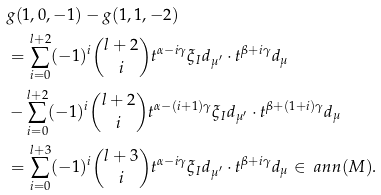<formula> <loc_0><loc_0><loc_500><loc_500>& g ( 1 , 0 , - 1 ) - g ( 1 , 1 , - 2 ) \\ & = \sum _ { i = 0 } ^ { l + 2 } ( - 1 ) ^ { i } \binom { l + 2 } i t ^ { \alpha - i \gamma } \xi _ { I } d _ { \mu ^ { \prime } } \cdot t ^ { \beta + i \gamma } d _ { \mu } \\ & - \sum _ { i = 0 } ^ { l + 2 } ( - 1 ) ^ { i } \binom { l + 2 } i t ^ { \alpha - ( i + 1 ) \gamma } \xi _ { I } d _ { \mu ^ { \prime } } \cdot t ^ { \beta + ( 1 + i ) \gamma } d _ { \mu } \\ & = \sum _ { i = 0 } ^ { l + 3 } ( - 1 ) ^ { i } \binom { l + 3 } i t ^ { \alpha - i \gamma } \xi _ { I } d _ { \mu ^ { \prime } } \cdot t ^ { \beta + i \gamma } d _ { \mu } \in \ a n n ( M ) .</formula> 